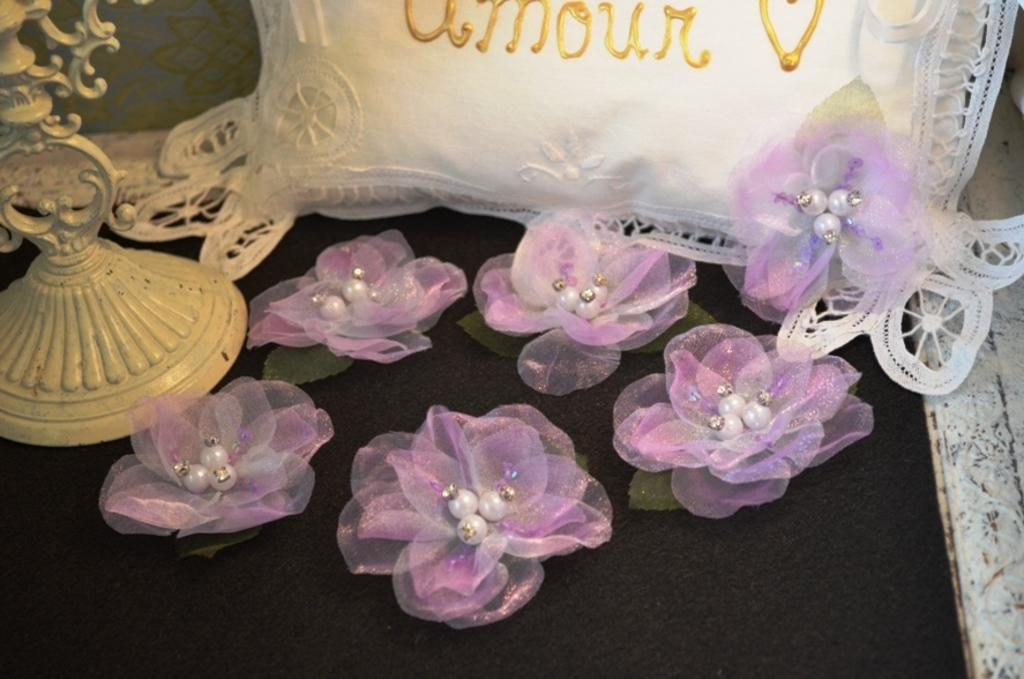What type of flowers are in the image? There are purple and white artificial flowers in the image. What is the color of the surface where the flowers are placed? The flowers are on a black surface. What type of object is visible in the image that is not a flower? There is a white color pillow in the image. What is the color of the cream-colored object in the image? There is a cream color object in the image. What type of silk fabric is draped over the vase in the image? There is no vase or silk fabric present in the image. 